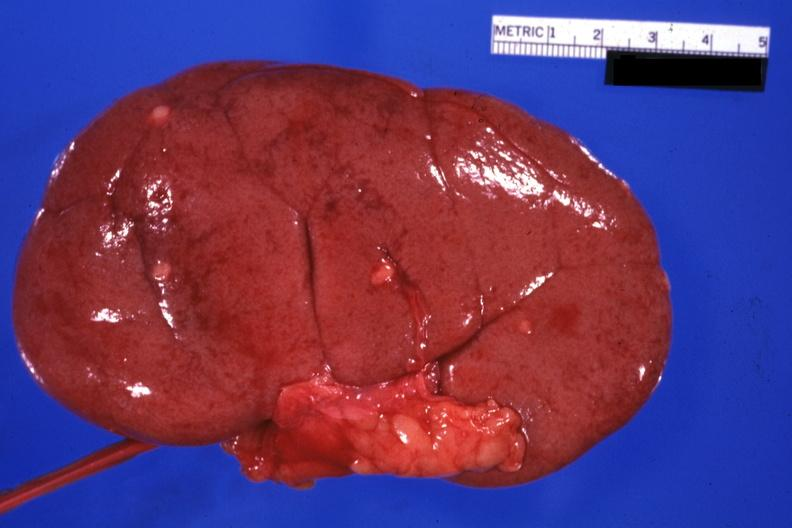what is present?
Answer the question using a single word or phrase. Metastatic carcinoma breast 